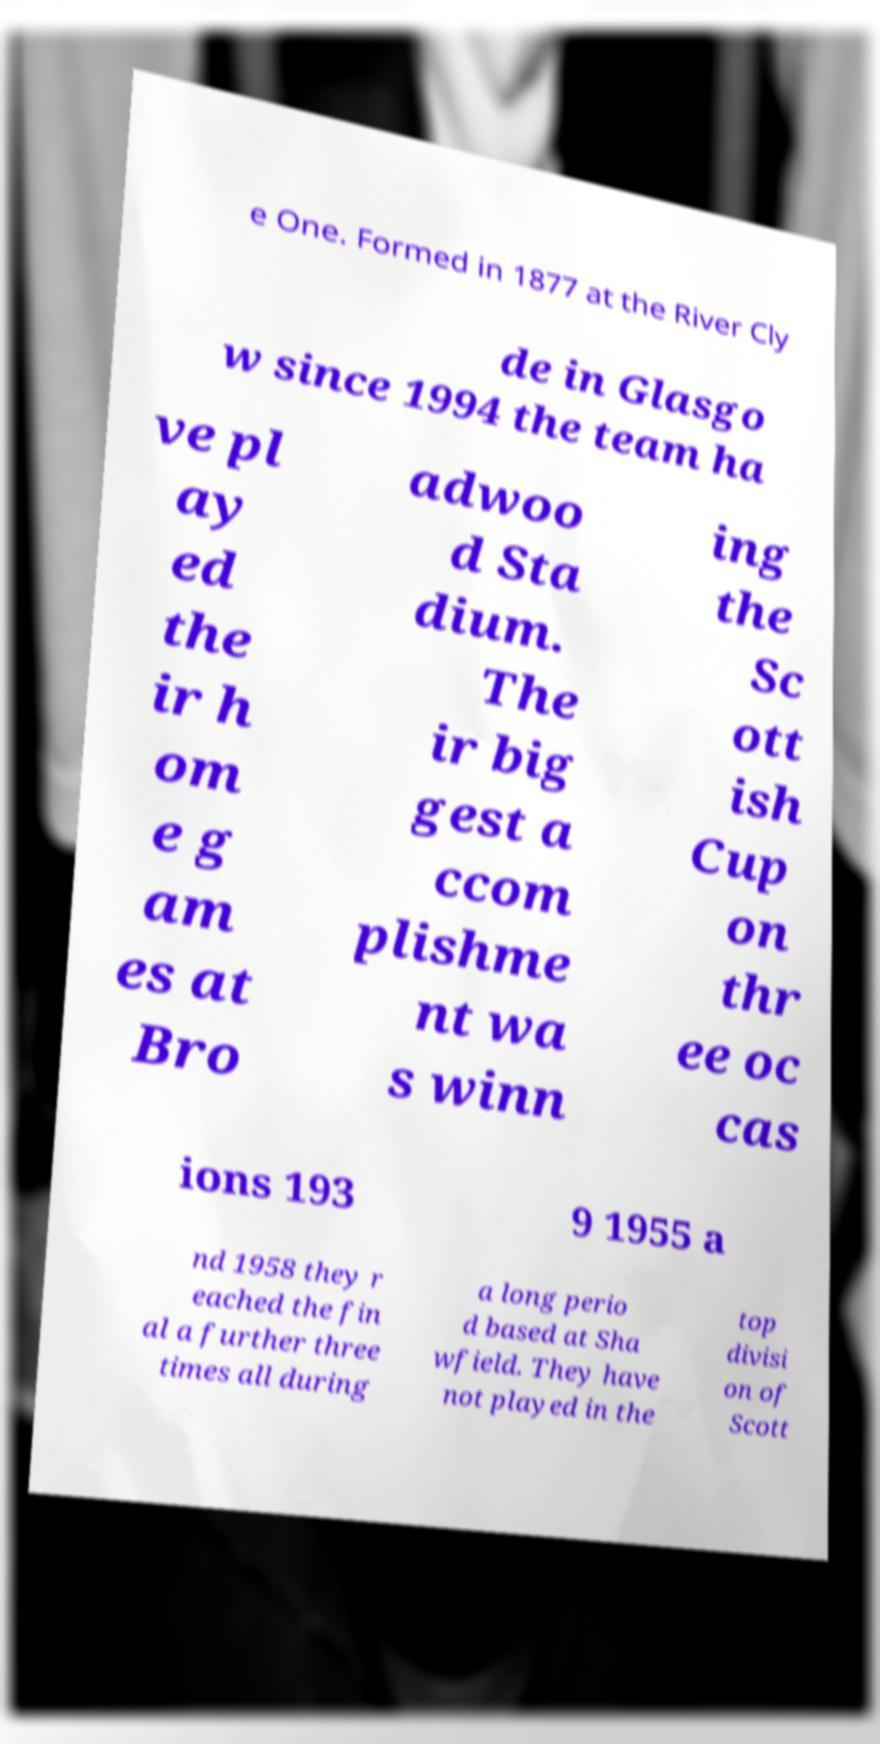Could you extract and type out the text from this image? e One. Formed in 1877 at the River Cly de in Glasgo w since 1994 the team ha ve pl ay ed the ir h om e g am es at Bro adwoo d Sta dium. The ir big gest a ccom plishme nt wa s winn ing the Sc ott ish Cup on thr ee oc cas ions 193 9 1955 a nd 1958 they r eached the fin al a further three times all during a long perio d based at Sha wfield. They have not played in the top divisi on of Scott 